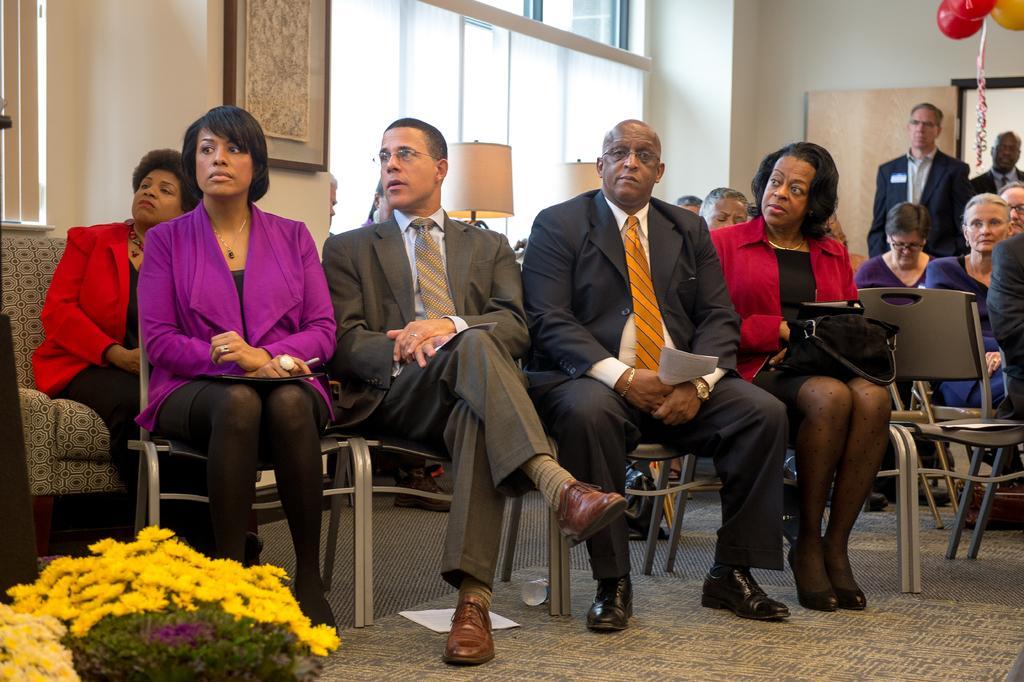Could you give a brief overview of what you see in this image? In this picture we can observe some people sitting in the chairs. There are men and women in this picture. On the left side there are yellow color flowers placed on the floor. We can observe red and yellow color balloons on the right side. In the background there is a wall. We can observe windows and two lamps. 